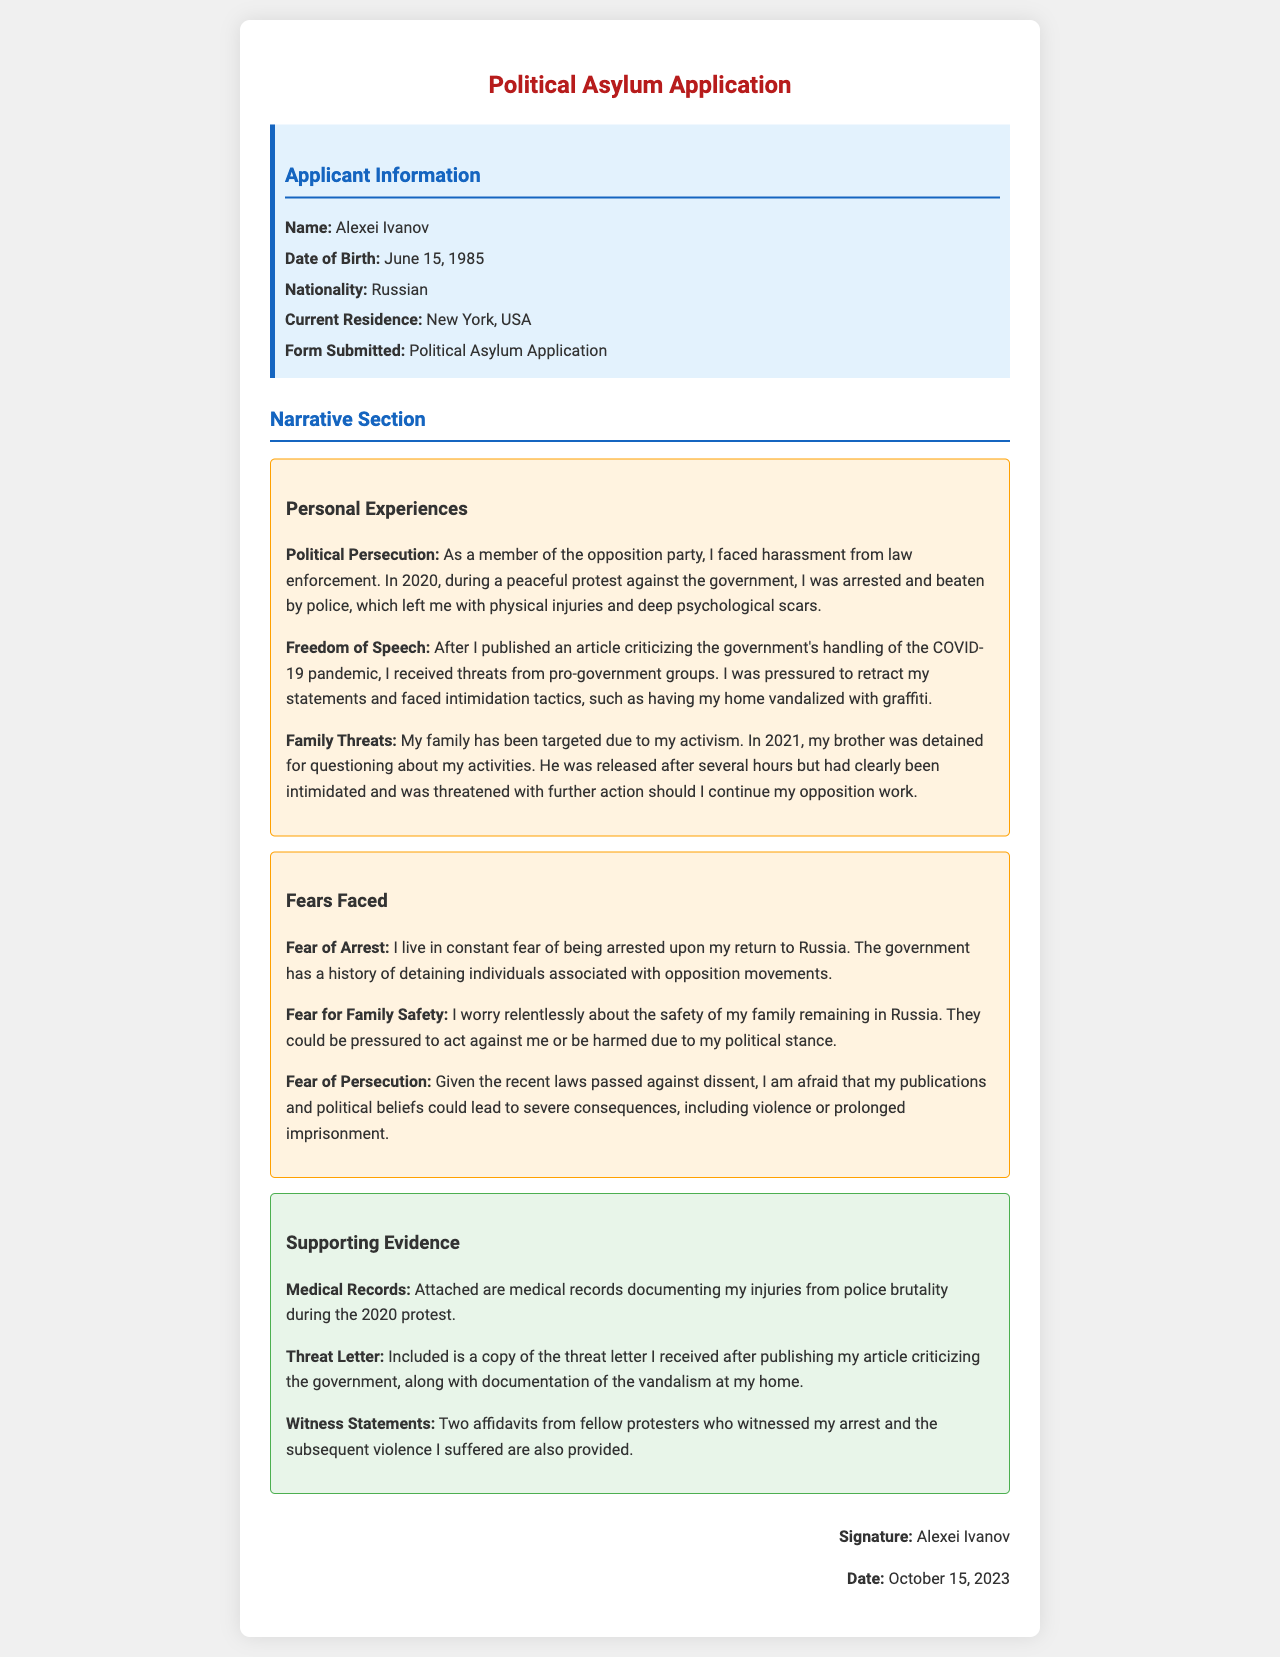what is the applicant's name? The applicant's name is provided in the information box of the document.
Answer: Alexei Ivanov what is the applicant's date of birth? The date of birth is listed under the applicant information section.
Answer: June 15, 1985 what political party is the applicant associated with? The document mentions the applicant's political affiliation in the narrative section.
Answer: opposition party in what year did the applicant face police brutality? The narrative section specifies the year of the incident involving police brutality.
Answer: 2020 what is one fear expressed by the applicant regarding their return to Russia? The fears faced by the applicant are detailed in the narrative section.
Answer: Fear of Arrest what document is included as evidence of threats received? The supporting evidence section lists specific documents as evidence of threats.
Answer: threat letter how many affidavits from fellow protesters are provided? The number of affidavits is mentioned in the evidence section of the document.
Answer: two what country is the applicant currently residing in? The current residence is stated in the applicant information box.
Answer: New York, USA what type of records are attached to support the applicant's claims? The supporting evidence section outlines the types of records attached.
Answer: Medical Records 